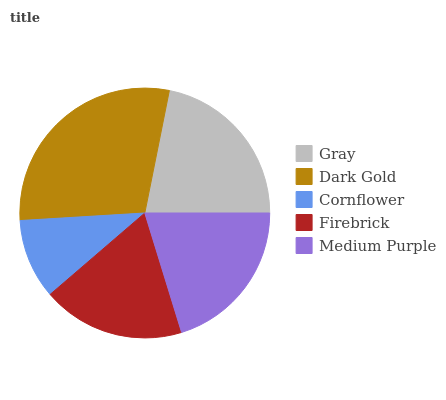Is Cornflower the minimum?
Answer yes or no. Yes. Is Dark Gold the maximum?
Answer yes or no. Yes. Is Dark Gold the minimum?
Answer yes or no. No. Is Cornflower the maximum?
Answer yes or no. No. Is Dark Gold greater than Cornflower?
Answer yes or no. Yes. Is Cornflower less than Dark Gold?
Answer yes or no. Yes. Is Cornflower greater than Dark Gold?
Answer yes or no. No. Is Dark Gold less than Cornflower?
Answer yes or no. No. Is Medium Purple the high median?
Answer yes or no. Yes. Is Medium Purple the low median?
Answer yes or no. Yes. Is Firebrick the high median?
Answer yes or no. No. Is Dark Gold the low median?
Answer yes or no. No. 